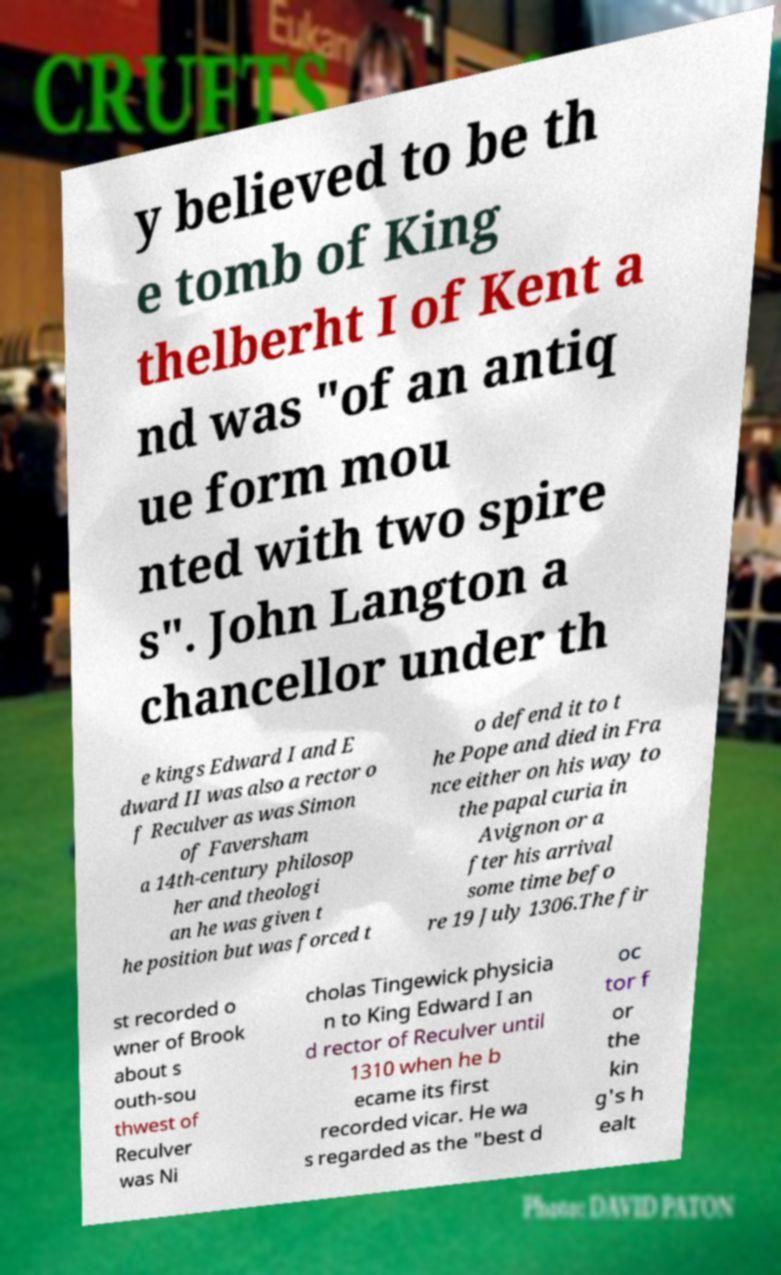Can you read and provide the text displayed in the image?This photo seems to have some interesting text. Can you extract and type it out for me? y believed to be th e tomb of King thelberht I of Kent a nd was "of an antiq ue form mou nted with two spire s". John Langton a chancellor under th e kings Edward I and E dward II was also a rector o f Reculver as was Simon of Faversham a 14th-century philosop her and theologi an he was given t he position but was forced t o defend it to t he Pope and died in Fra nce either on his way to the papal curia in Avignon or a fter his arrival some time befo re 19 July 1306.The fir st recorded o wner of Brook about s outh-sou thwest of Reculver was Ni cholas Tingewick physicia n to King Edward I an d rector of Reculver until 1310 when he b ecame its first recorded vicar. He wa s regarded as the "best d oc tor f or the kin g's h ealt 